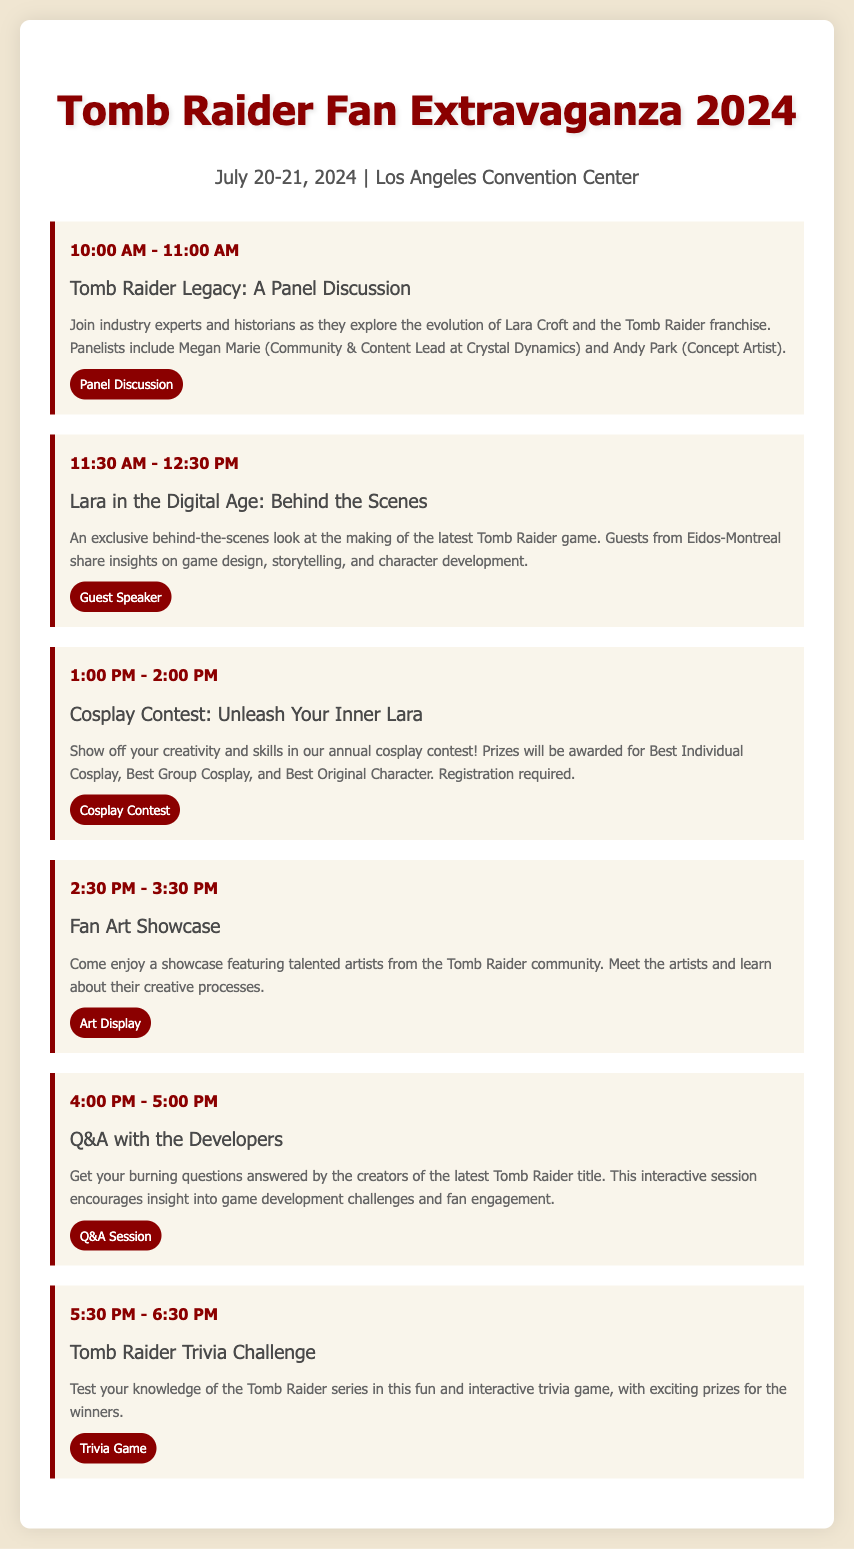what is the date of the event? The date of the event is provided in the document as July 20-21, 2024.
Answer: July 20-21, 2024 where is the event taking place? The document specifies that the event will be held at the Los Angeles Convention Center.
Answer: Los Angeles Convention Center who is a panelist in the "Tomb Raider Legacy" discussion? The document mentions Megan Marie as a panelist in that discussion.
Answer: Megan Marie what type of session is the "Lara in the Digital Age" presentation? The document categorizes it as a Guest Speaker session.
Answer: Guest Speaker how long is the "Cosplay Contest" scheduled for? The document indicates that the "Cosplay Contest" is scheduled for one hour.
Answer: 1 hour what prize categories are mentioned for the Cosplay Contest? The document lists Best Individual Cosplay, Best Group Cosplay, and Best Original Character as prize categories.
Answer: Best Individual Cosplay, Best Group Cosplay, Best Original Character which session features a trivia game? The session titled "Tomb Raider Trivia Challenge" includes a trivia game.
Answer: Tomb Raider Trivia Challenge how many agenda items are there in total? By counting the listed sessions, the total number of agenda items can be determined to be six.
Answer: 6 what is the time for the Q&A with the Developers session? The document specifies that the Q&A with the Developers session is from 4:00 PM to 5:00 PM.
Answer: 4:00 PM - 5:00 PM 